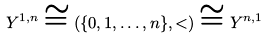Convert formula to latex. <formula><loc_0><loc_0><loc_500><loc_500>Y ^ { 1 , n } \cong ( \{ 0 , 1 , \dots , n \} , < ) \cong Y ^ { n , 1 }</formula> 